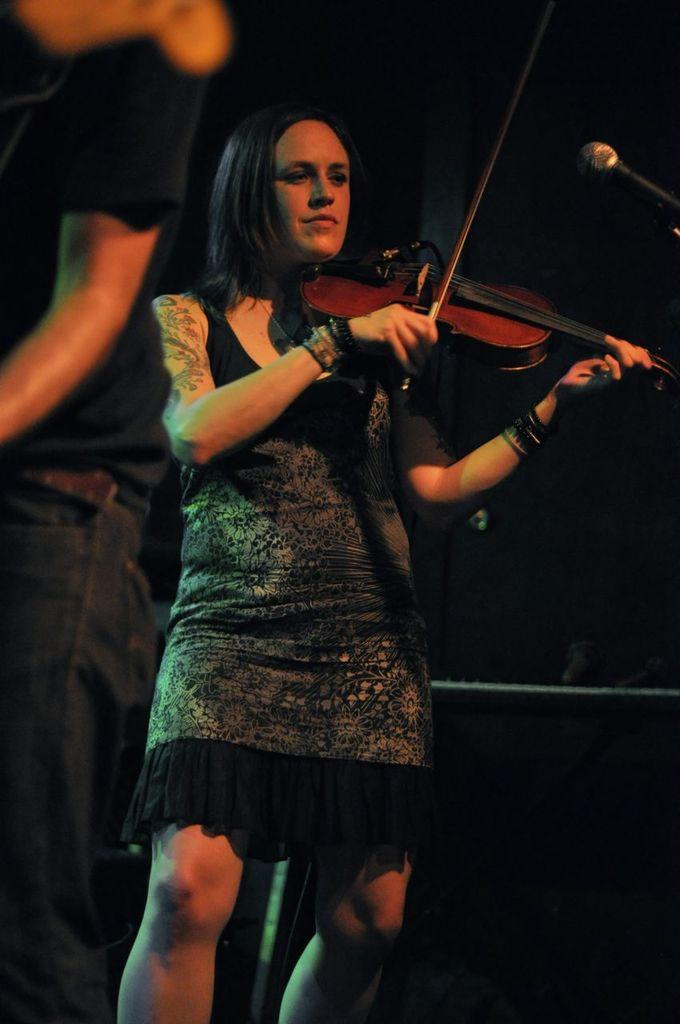Who is the main subject in the image? There is a lady in the center of the image. What is the lady doing in the image? The lady is standing and holding a violin in her hand. What object is present in the image that is typically used for amplifying sound? There is a microphone in the image. Who else is present in the image besides the lady? There is a man standing on the left side of the image. What type of pie is being served to the cat in the image? There is no cat or pie present in the image. What order is the lady following while playing the violin in the image? The image does not provide information about the order of the music being played by the lady. 